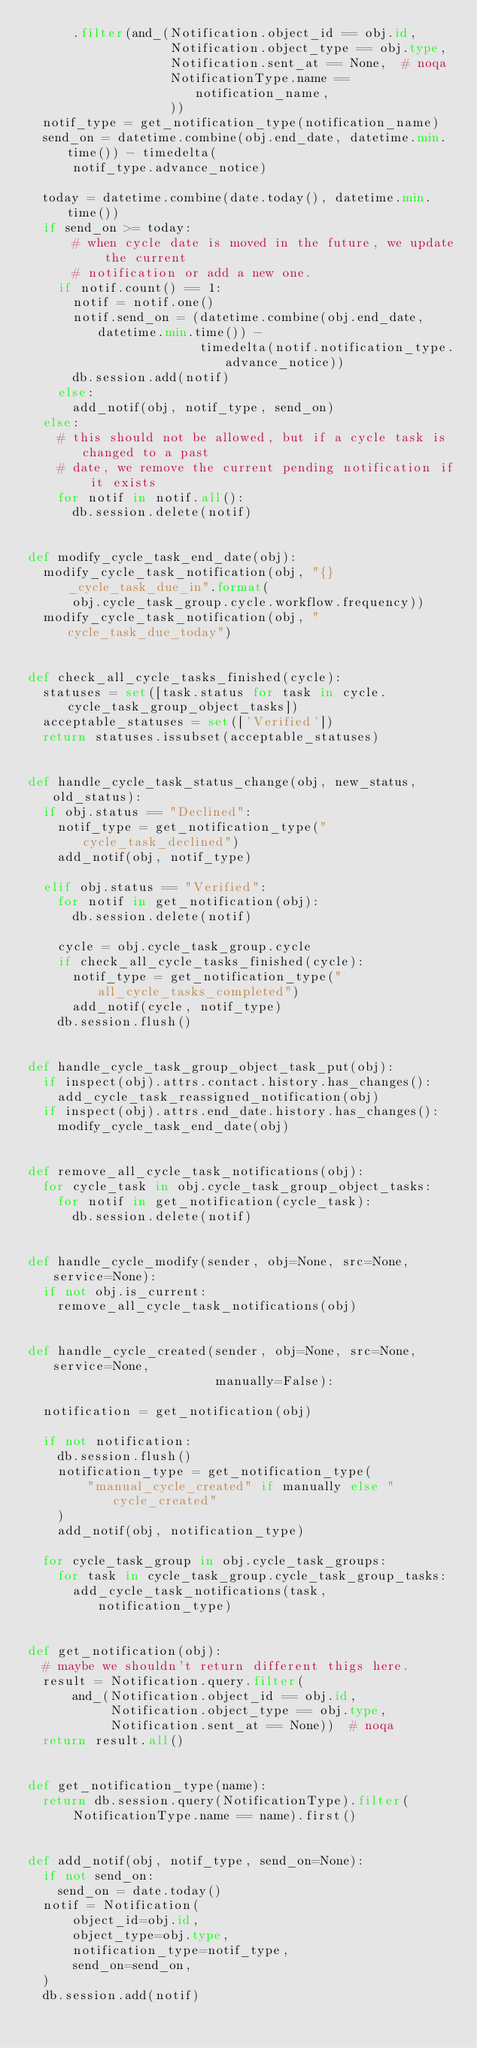Convert code to text. <code><loc_0><loc_0><loc_500><loc_500><_Python_>      .filter(and_(Notification.object_id == obj.id,
                   Notification.object_type == obj.type,
                   Notification.sent_at == None,  # noqa
                   NotificationType.name == notification_name,
                   ))
  notif_type = get_notification_type(notification_name)
  send_on = datetime.combine(obj.end_date, datetime.min.time()) - timedelta(
      notif_type.advance_notice)

  today = datetime.combine(date.today(), datetime.min.time())
  if send_on >= today:
      # when cycle date is moved in the future, we update the current
      # notification or add a new one.
    if notif.count() == 1:
      notif = notif.one()
      notif.send_on = (datetime.combine(obj.end_date, datetime.min.time()) -
                       timedelta(notif.notification_type.advance_notice))
      db.session.add(notif)
    else:
      add_notif(obj, notif_type, send_on)
  else:
    # this should not be allowed, but if a cycle task is changed to a past
    # date, we remove the current pending notification if it exists
    for notif in notif.all():
      db.session.delete(notif)


def modify_cycle_task_end_date(obj):
  modify_cycle_task_notification(obj, "{}_cycle_task_due_in".format(
      obj.cycle_task_group.cycle.workflow.frequency))
  modify_cycle_task_notification(obj, "cycle_task_due_today")


def check_all_cycle_tasks_finished(cycle):
  statuses = set([task.status for task in cycle.cycle_task_group_object_tasks])
  acceptable_statuses = set(['Verified'])
  return statuses.issubset(acceptable_statuses)


def handle_cycle_task_status_change(obj, new_status, old_status):
  if obj.status == "Declined":
    notif_type = get_notification_type("cycle_task_declined")
    add_notif(obj, notif_type)

  elif obj.status == "Verified":
    for notif in get_notification(obj):
      db.session.delete(notif)

    cycle = obj.cycle_task_group.cycle
    if check_all_cycle_tasks_finished(cycle):
      notif_type = get_notification_type("all_cycle_tasks_completed")
      add_notif(cycle, notif_type)
    db.session.flush()


def handle_cycle_task_group_object_task_put(obj):
  if inspect(obj).attrs.contact.history.has_changes():
    add_cycle_task_reassigned_notification(obj)
  if inspect(obj).attrs.end_date.history.has_changes():
    modify_cycle_task_end_date(obj)


def remove_all_cycle_task_notifications(obj):
  for cycle_task in obj.cycle_task_group_object_tasks:
    for notif in get_notification(cycle_task):
      db.session.delete(notif)


def handle_cycle_modify(sender, obj=None, src=None, service=None):
  if not obj.is_current:
    remove_all_cycle_task_notifications(obj)


def handle_cycle_created(sender, obj=None, src=None, service=None,
                         manually=False):

  notification = get_notification(obj)

  if not notification:
    db.session.flush()
    notification_type = get_notification_type(
        "manual_cycle_created" if manually else "cycle_created"
    )
    add_notif(obj, notification_type)

  for cycle_task_group in obj.cycle_task_groups:
    for task in cycle_task_group.cycle_task_group_tasks:
      add_cycle_task_notifications(task, notification_type)


def get_notification(obj):
  # maybe we shouldn't return different thigs here.
  result = Notification.query.filter(
      and_(Notification.object_id == obj.id,
           Notification.object_type == obj.type,
           Notification.sent_at == None))  # noqa
  return result.all()


def get_notification_type(name):
  return db.session.query(NotificationType).filter(
      NotificationType.name == name).first()


def add_notif(obj, notif_type, send_on=None):
  if not send_on:
    send_on = date.today()
  notif = Notification(
      object_id=obj.id,
      object_type=obj.type,
      notification_type=notif_type,
      send_on=send_on,
  )
  db.session.add(notif)
</code> 